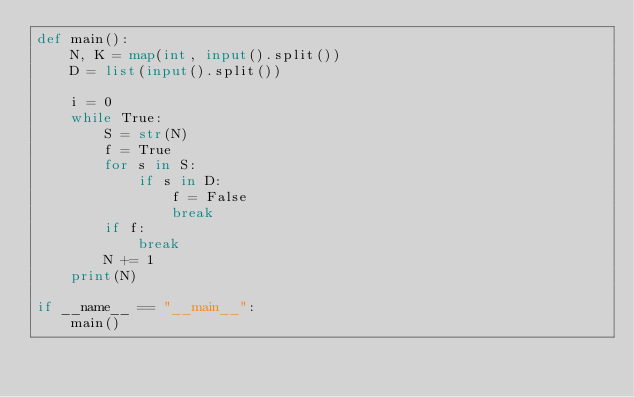Convert code to text. <code><loc_0><loc_0><loc_500><loc_500><_Python_>def main():
    N, K = map(int, input().split())
    D = list(input().split())

    i = 0
    while True:
        S = str(N)
        f = True
        for s in S:
            if s in D:
                f = False
                break
        if f:
            break
        N += 1
    print(N)
    
if __name__ == "__main__":
    main()</code> 